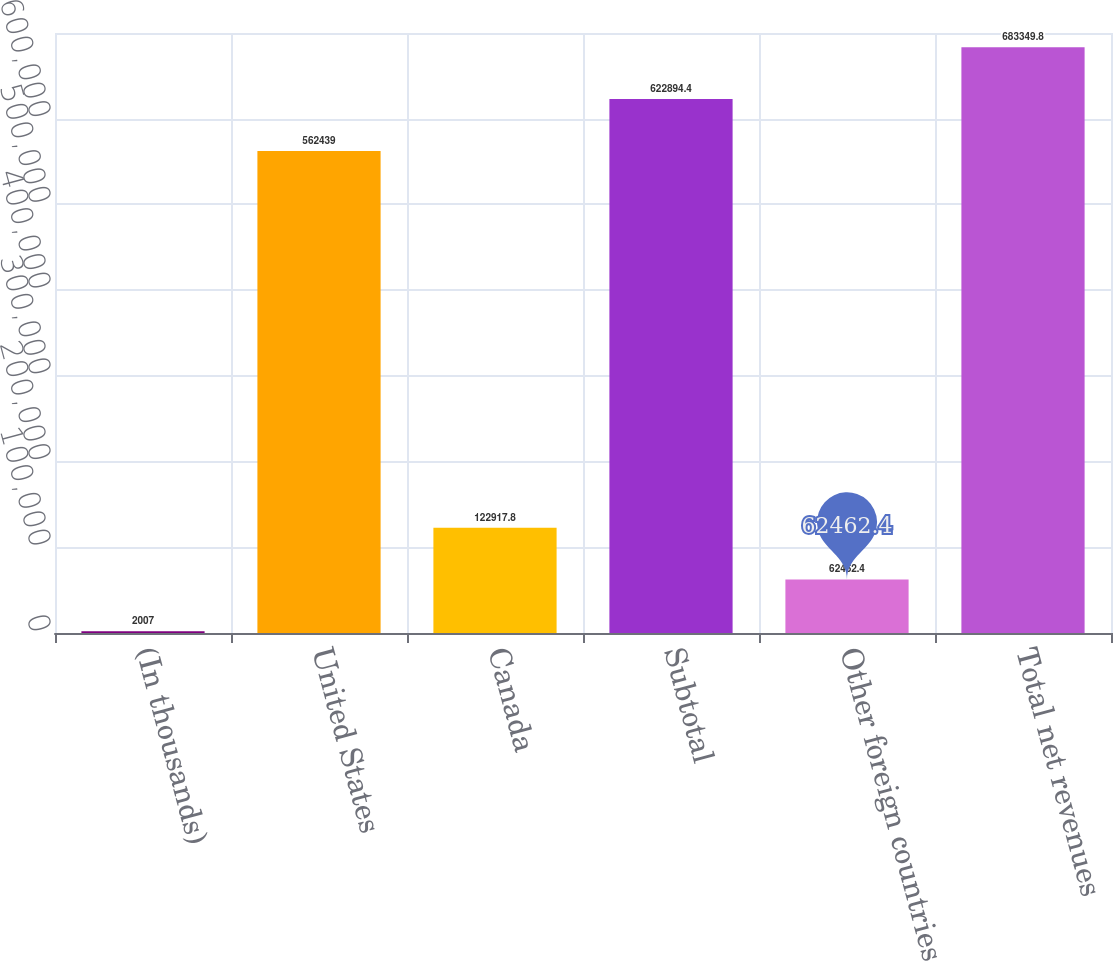Convert chart. <chart><loc_0><loc_0><loc_500><loc_500><bar_chart><fcel>(In thousands)<fcel>United States<fcel>Canada<fcel>Subtotal<fcel>Other foreign countries<fcel>Total net revenues<nl><fcel>2007<fcel>562439<fcel>122918<fcel>622894<fcel>62462.4<fcel>683350<nl></chart> 